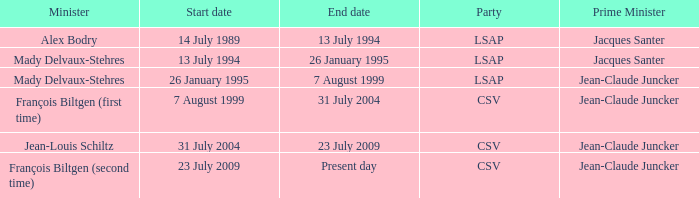Who was the minister for the CSV party with a present day end date? François Biltgen (second time). 